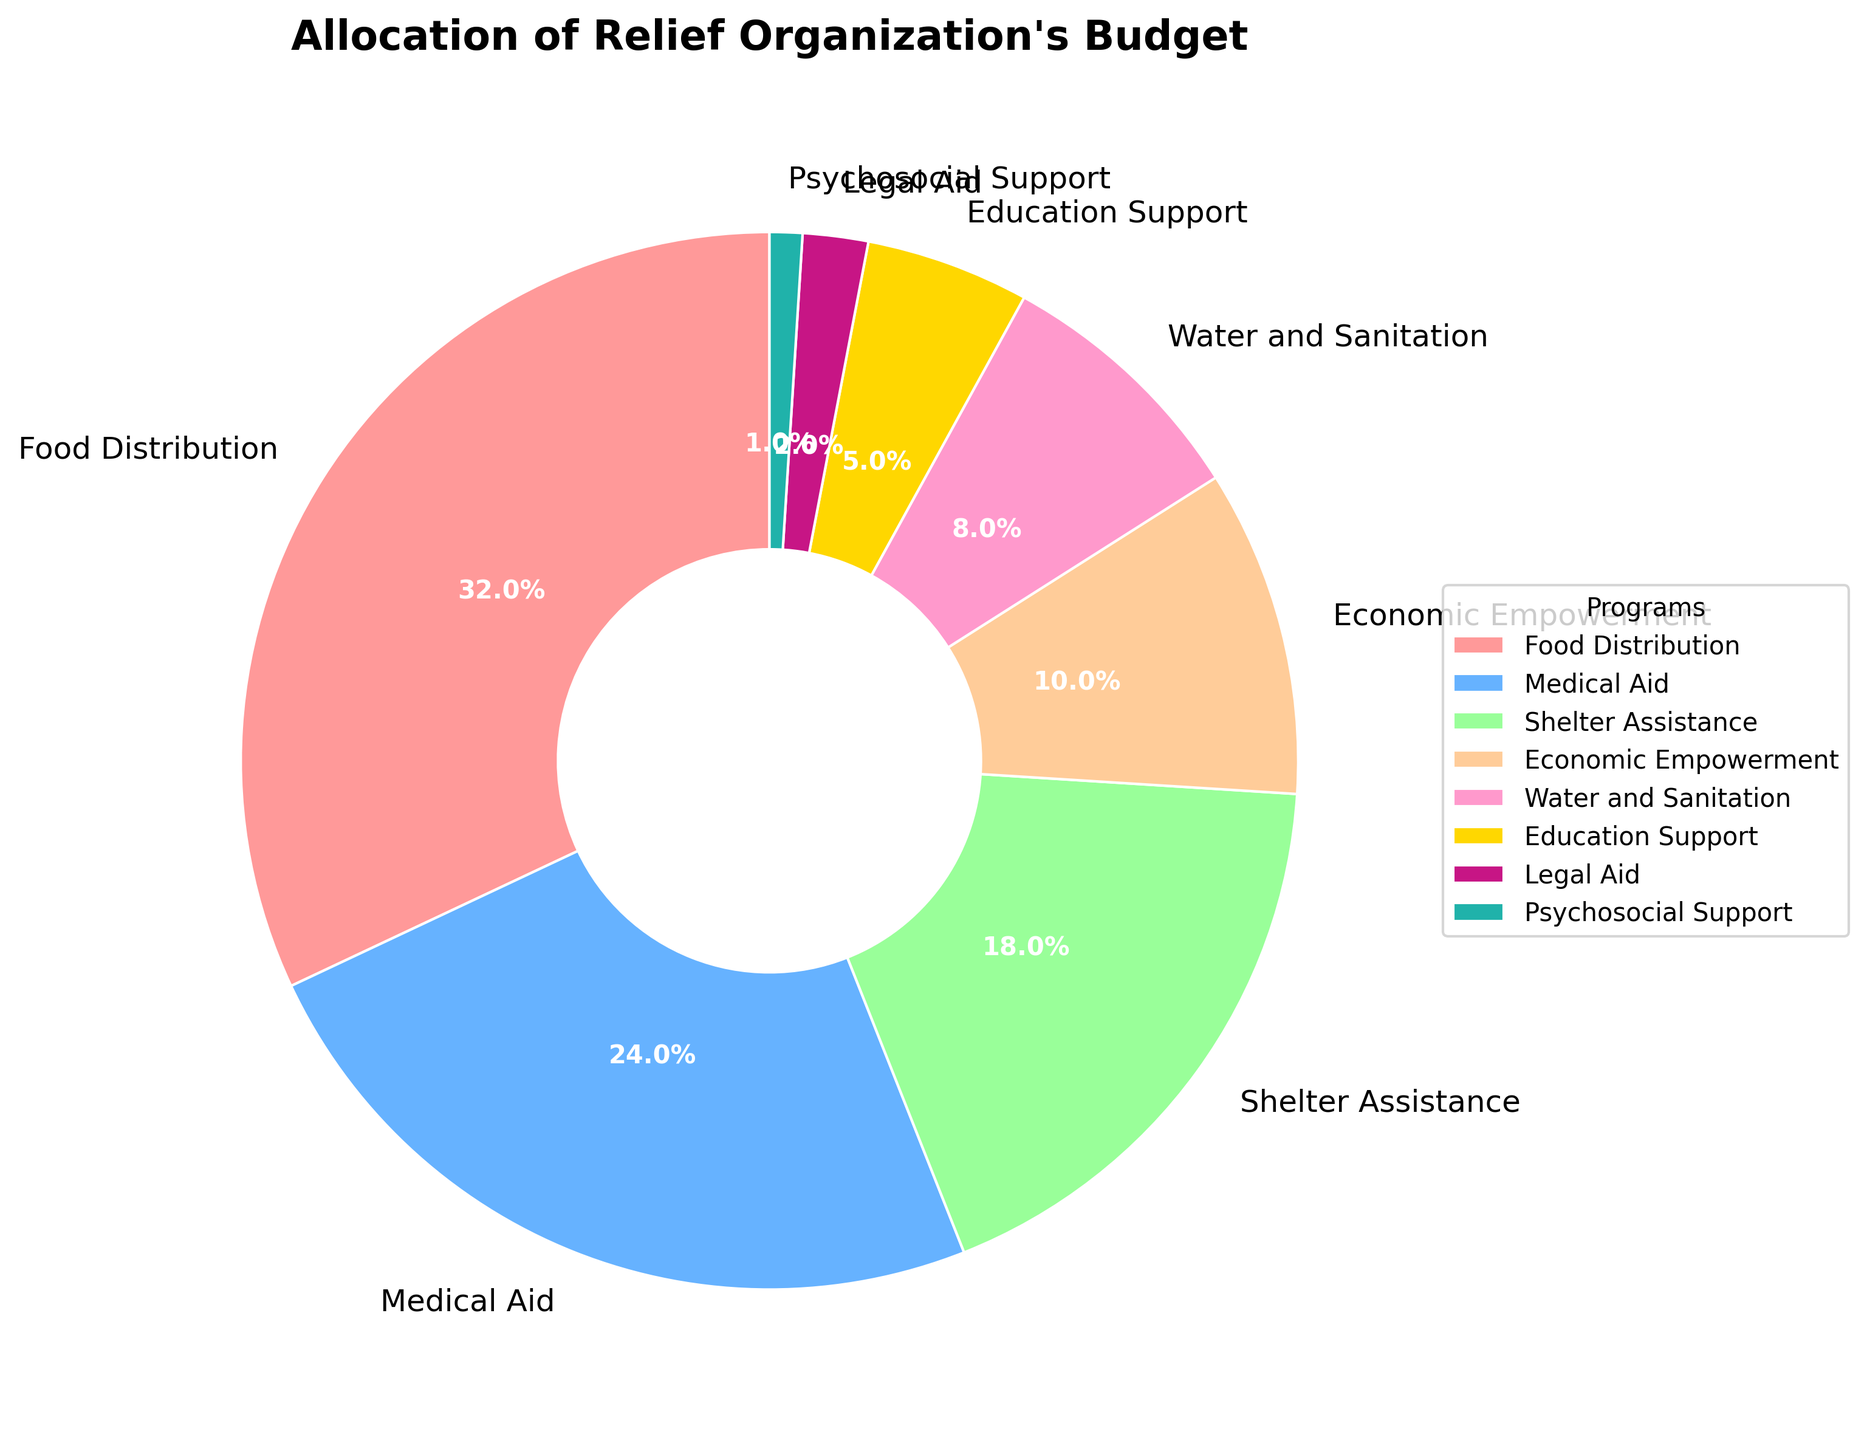What percentage of the budget is allocated to Medical Aid and Shelter Assistance combined? To find the combined percentage of the budget allocated to Medical Aid and Shelter Assistance, add their individual percentages. Medical Aid is 24% and Shelter Assistance is 18%. So, 24 + 18 = 42%.
Answer: 42% Which program receives the highest budget allocation? Look at the pie chart and identify the segment with the largest size. The label with the highest percentage represents the program with the highest budget allocation, which is Food Distribution at 32%.
Answer: Food Distribution How much more budget is allocated to Food Distribution compared to Economic Empowerment? To find the difference, subtract the budget of Economic Empowerment from Food Distribution. Food Distribution is 32% and Economic Empowerment is 10%. So, 32 - 10 = 22%.
Answer: 22% Which program receives the least amount of budget? Find the smallest segment in the pie chart and identify the corresponding label. The smallest segment is for Psychosocial Support, with a budget allocation of 1%.
Answer: Psychosocial Support Is more budget allocated to Education Support or Legal Aid? Compare the percentages for Education Support and Legal Aid in the pie chart. Education Support is allocated 5%, while Legal Aid is allocated 2%. So, more budget is allocated to Education Support.
Answer: Education Support What is the combined budget allocation for Water and Sanitation, Education Support, and Legal Aid? Add the budget allocations of Water and Sanitation, Education Support, and Legal Aid. Water and Sanitation is 8%, Education Support is 5%, and Legal Aid is 2%. So, 8 + 5 + 2 = 15%.
Answer: 15% Out of the programs listed, which two have the smallest budget allocations, and what are their percentages? Identify the two smallest segments from the pie chart. The two smallest segments are Psychosocial Support at 1% and Legal Aid at 2%.
Answer: Psychosocial Support (1%) and Legal Aid (2%) How much less is the budget allocation for Shelter Assistance compared to Food Distribution? Subtract the budget allocation of Shelter Assistance from Food Distribution. Food Distribution is 32% and Shelter Assistance is 18%. So, 32 - 18 = 14%.
Answer: 14% What is the total percentage of the budget allocated to the top three programs? Add the budget allocations of the top three programs: Food Distribution, Medical Aid, and Shelter Assistance. Food Distribution is 32%, Medical Aid is 24%, and Shelter Assistance is 18%. So, 32 + 24 + 18 = 74%.
Answer: 74% Which colored segment represents Medical Aid in the pie chart? Identify the color assigned to the segment labeled Medical Aid in the chart. Medical Aid is represented by the blue segment.
Answer: Blue 